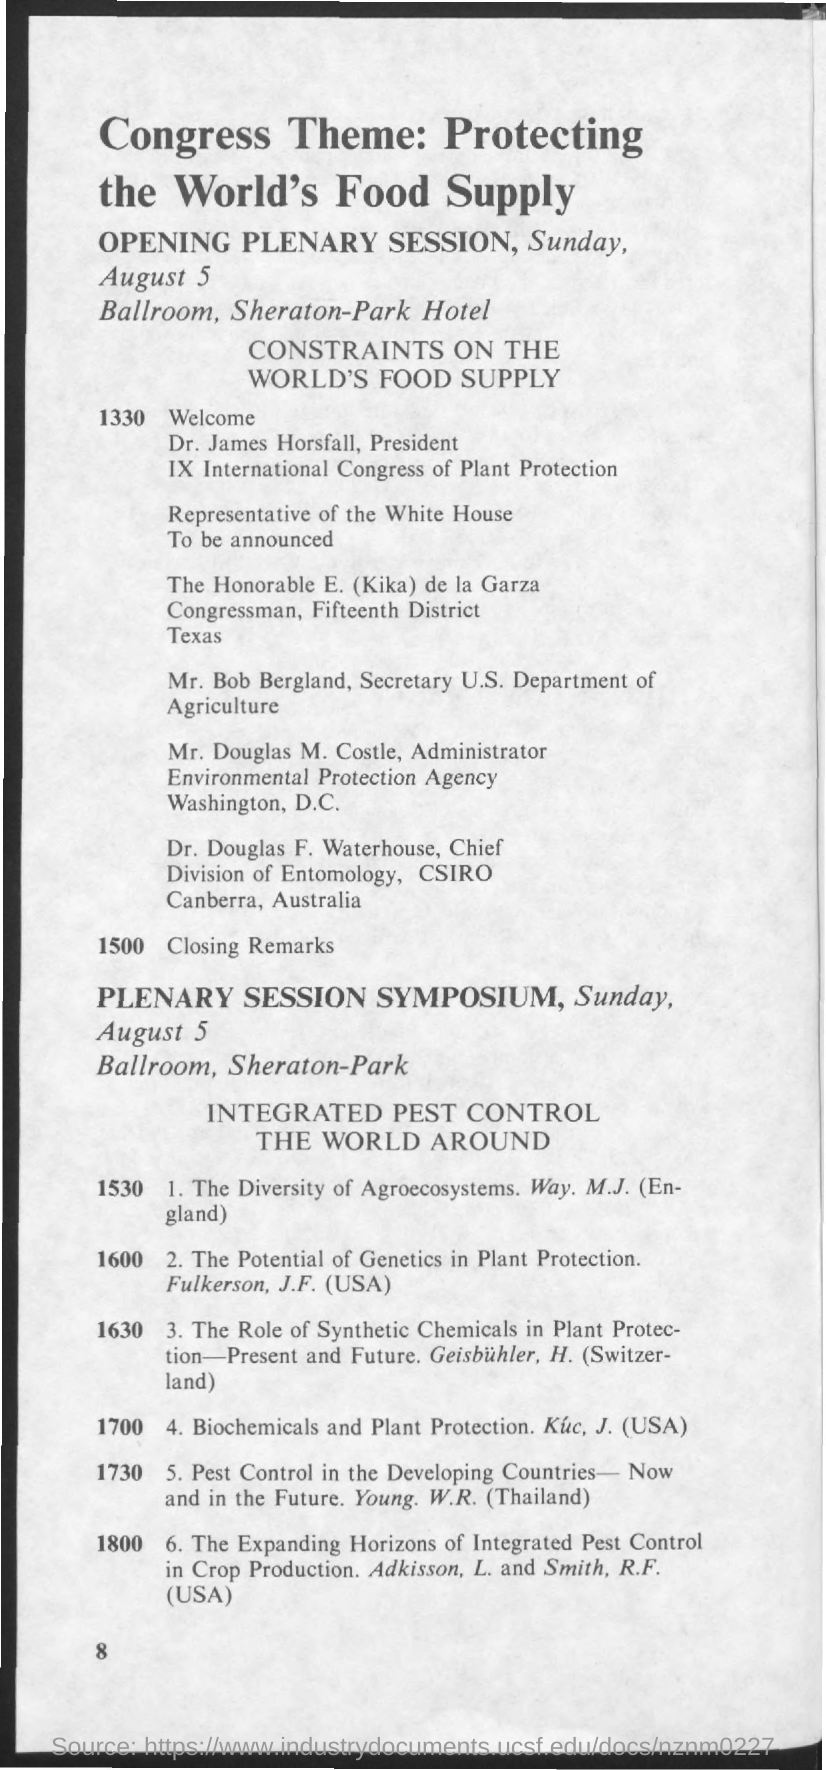Outline some significant characteristics in this image. It has been determined that Young.W.R is from Thailand. CSIRO, which is located in Australia, is a world-renowned research organization that conducts innovative studies in various fields. 